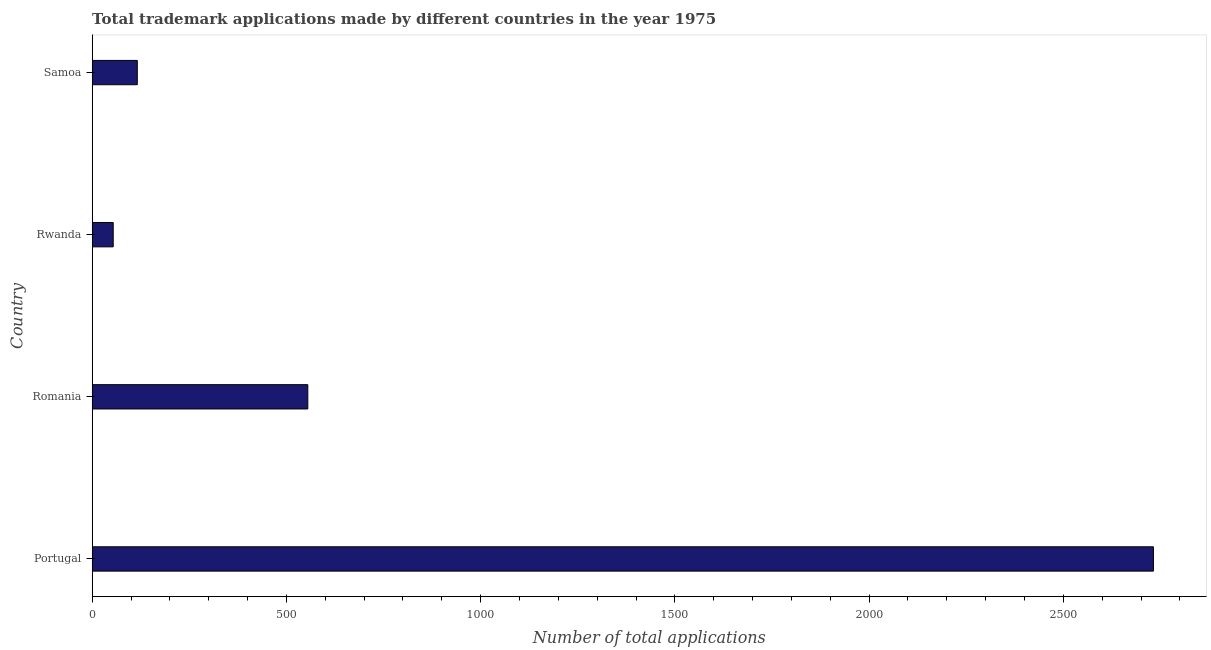Does the graph contain any zero values?
Keep it short and to the point. No. Does the graph contain grids?
Make the answer very short. No. What is the title of the graph?
Your answer should be compact. Total trademark applications made by different countries in the year 1975. What is the label or title of the X-axis?
Keep it short and to the point. Number of total applications. What is the number of trademark applications in Portugal?
Offer a very short reply. 2732. Across all countries, what is the maximum number of trademark applications?
Your answer should be very brief. 2732. Across all countries, what is the minimum number of trademark applications?
Provide a succinct answer. 54. In which country was the number of trademark applications maximum?
Ensure brevity in your answer.  Portugal. In which country was the number of trademark applications minimum?
Make the answer very short. Rwanda. What is the sum of the number of trademark applications?
Your response must be concise. 3457. What is the difference between the number of trademark applications in Rwanda and Samoa?
Your answer should be very brief. -62. What is the average number of trademark applications per country?
Your answer should be compact. 864. What is the median number of trademark applications?
Keep it short and to the point. 335.5. What is the ratio of the number of trademark applications in Romania to that in Samoa?
Offer a very short reply. 4.78. What is the difference between the highest and the second highest number of trademark applications?
Make the answer very short. 2177. What is the difference between the highest and the lowest number of trademark applications?
Ensure brevity in your answer.  2678. How many bars are there?
Provide a short and direct response. 4. How many countries are there in the graph?
Keep it short and to the point. 4. What is the difference between two consecutive major ticks on the X-axis?
Make the answer very short. 500. Are the values on the major ticks of X-axis written in scientific E-notation?
Provide a short and direct response. No. What is the Number of total applications of Portugal?
Make the answer very short. 2732. What is the Number of total applications of Romania?
Your response must be concise. 555. What is the Number of total applications in Rwanda?
Keep it short and to the point. 54. What is the Number of total applications of Samoa?
Keep it short and to the point. 116. What is the difference between the Number of total applications in Portugal and Romania?
Offer a terse response. 2177. What is the difference between the Number of total applications in Portugal and Rwanda?
Your response must be concise. 2678. What is the difference between the Number of total applications in Portugal and Samoa?
Your answer should be very brief. 2616. What is the difference between the Number of total applications in Romania and Rwanda?
Give a very brief answer. 501. What is the difference between the Number of total applications in Romania and Samoa?
Your response must be concise. 439. What is the difference between the Number of total applications in Rwanda and Samoa?
Provide a succinct answer. -62. What is the ratio of the Number of total applications in Portugal to that in Romania?
Your answer should be compact. 4.92. What is the ratio of the Number of total applications in Portugal to that in Rwanda?
Give a very brief answer. 50.59. What is the ratio of the Number of total applications in Portugal to that in Samoa?
Provide a short and direct response. 23.55. What is the ratio of the Number of total applications in Romania to that in Rwanda?
Make the answer very short. 10.28. What is the ratio of the Number of total applications in Romania to that in Samoa?
Your answer should be very brief. 4.78. What is the ratio of the Number of total applications in Rwanda to that in Samoa?
Ensure brevity in your answer.  0.47. 